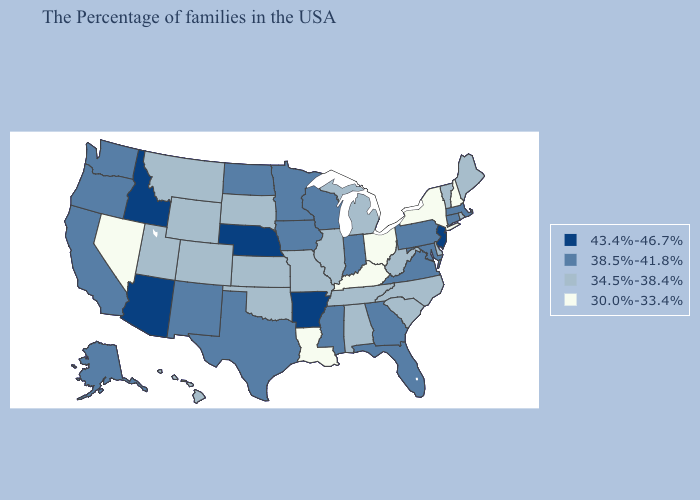Name the states that have a value in the range 30.0%-33.4%?
Quick response, please. New Hampshire, New York, Ohio, Kentucky, Louisiana, Nevada. Name the states that have a value in the range 43.4%-46.7%?
Be succinct. New Jersey, Arkansas, Nebraska, Arizona, Idaho. Does the first symbol in the legend represent the smallest category?
Be succinct. No. Which states hav the highest value in the Northeast?
Write a very short answer. New Jersey. Does the first symbol in the legend represent the smallest category?
Answer briefly. No. Does Georgia have the lowest value in the South?
Answer briefly. No. What is the value of Iowa?
Short answer required. 38.5%-41.8%. What is the lowest value in the USA?
Keep it brief. 30.0%-33.4%. Does Idaho have a higher value than Indiana?
Give a very brief answer. Yes. What is the value of New Hampshire?
Concise answer only. 30.0%-33.4%. Which states have the lowest value in the USA?
Concise answer only. New Hampshire, New York, Ohio, Kentucky, Louisiana, Nevada. What is the highest value in the USA?
Short answer required. 43.4%-46.7%. Is the legend a continuous bar?
Concise answer only. No. Which states have the lowest value in the West?
Answer briefly. Nevada. What is the value of Mississippi?
Answer briefly. 38.5%-41.8%. 